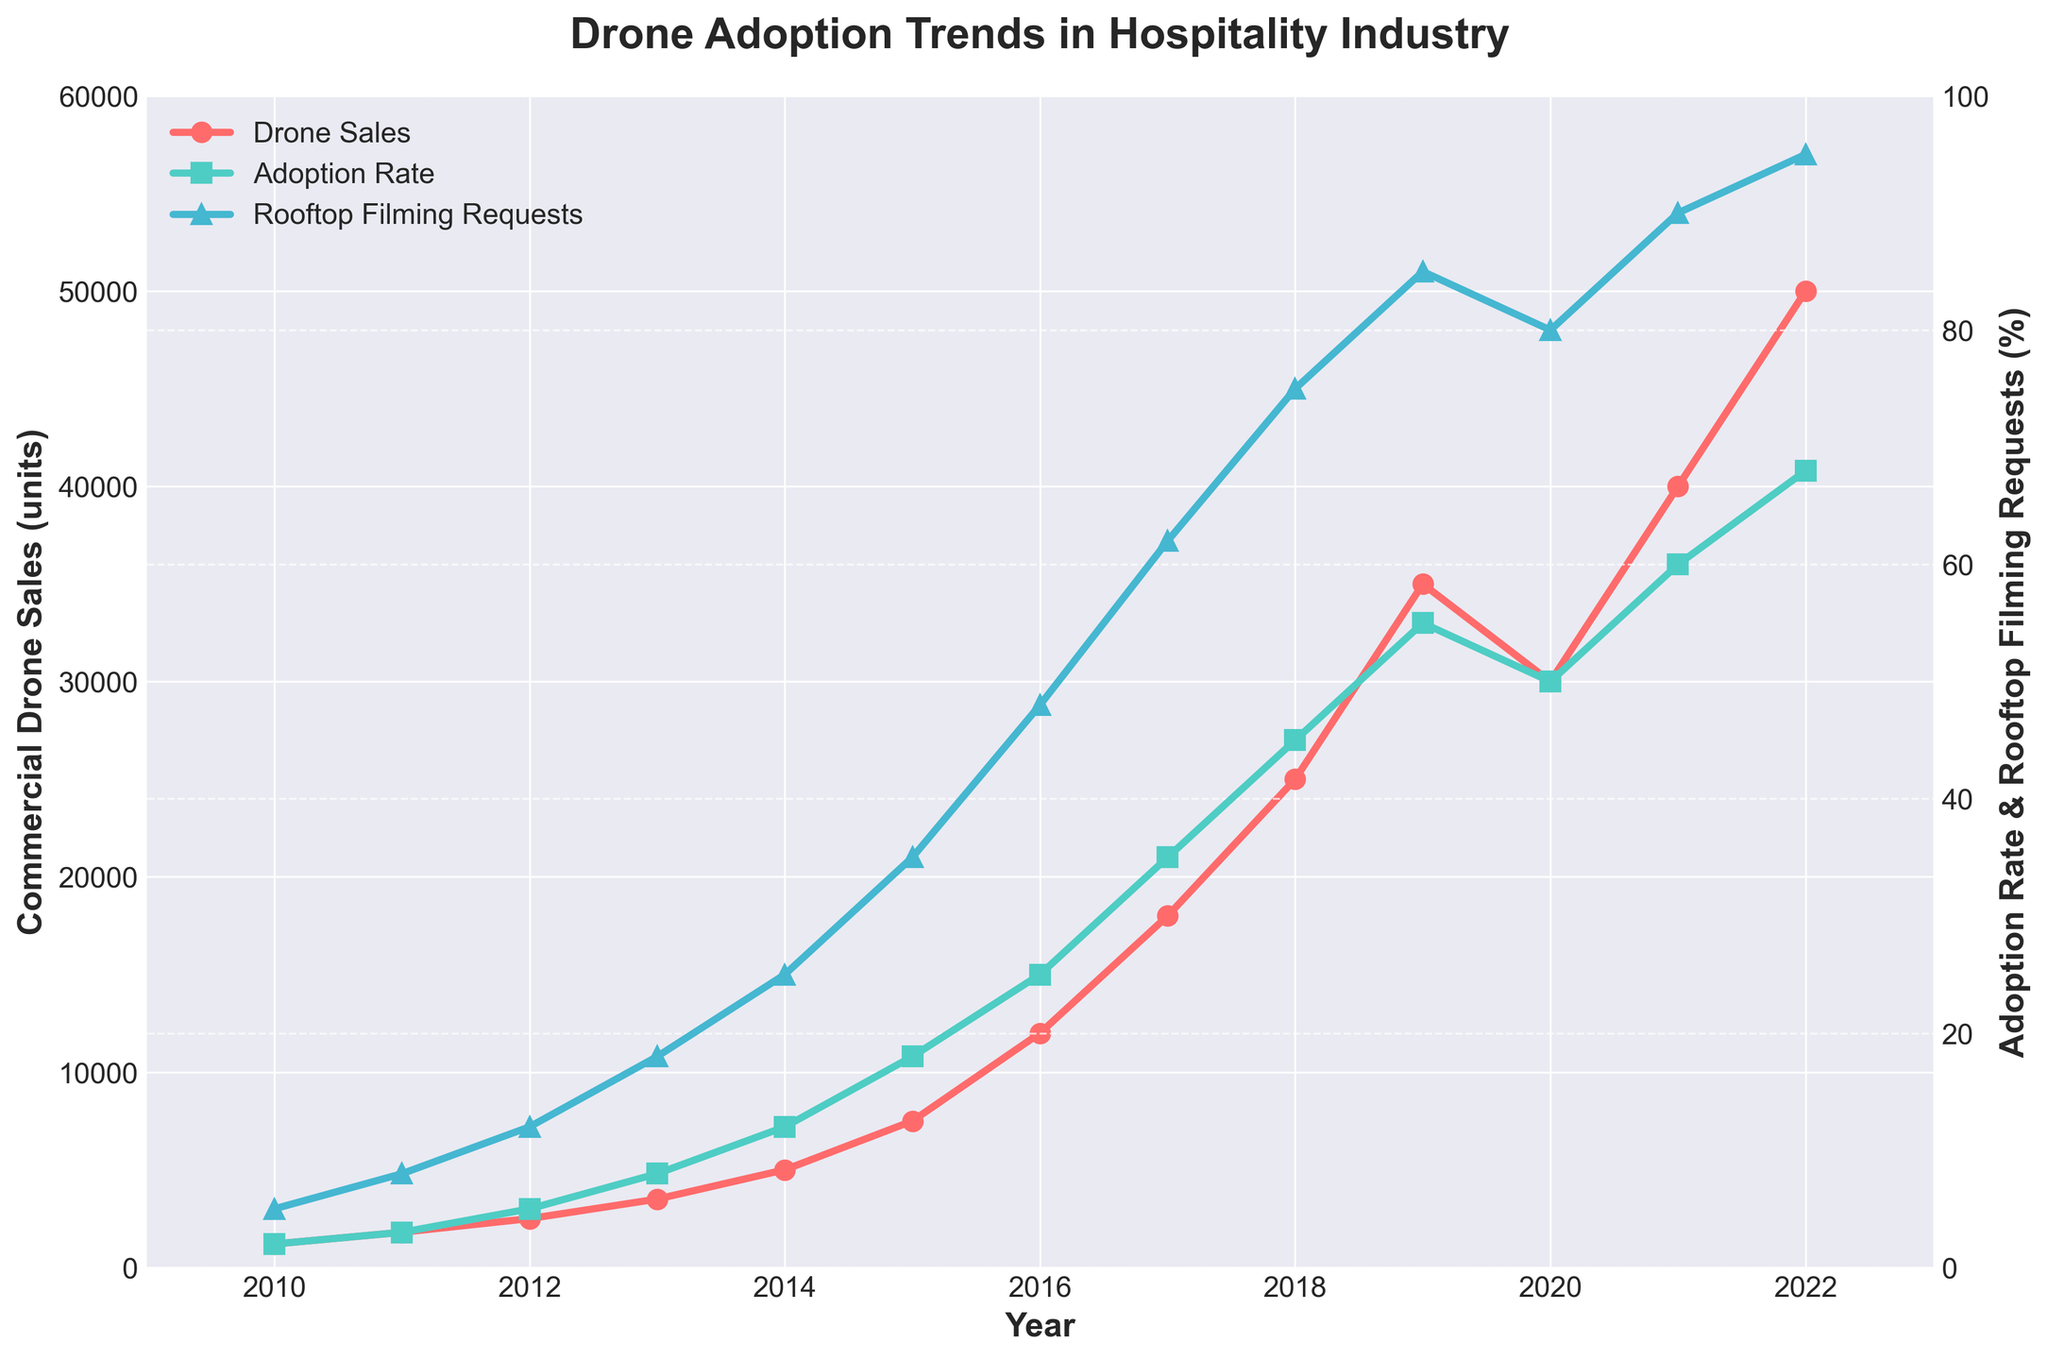what's the trend in commercial drone sales between 2010 and 2022? The data plot shows a steady upward trend in commercial drone sales, increasing from 1200 units in 2010 to 50000 units in 2022. This indicates growing adoption and market expansion over the period.
Answer: Increasing steadily what year shows the highest adoption rate in the hospitality industry? By observing the line for the hospitality industry adoption rate, the year 2022 demonstrates the highest adoption rate at 68%.
Answer: 2022 How does the adoption rate in the hospitality industry and the number of rooftop filming requests compare in 2016? The adoption rate for the hospitality industry in 2016 is around 25%, while the number of rooftop filming requests is around 48%. Thus, the rooftop filming requests are higher.
Answer: Rooftop filming requests are higher What is the average drone price trend from 2010 to 2022? The plot shows that the average drone price is decreasing over time, from $3500 in 2010 to $950 in 2022. This indicates that drones have become more affordable over the years.
Answer: Decreasing Did the DJI market share increase or decrease from 2010 to 2022? The plot shows that DJI market share increased from 45% in 2010 to 82% in 2022, highlighting DJI's growing dominance in the market.
Answer: Increased In which year did the rooftop filming requests reach 62%? By observing the line for rooftop filming requests, it reaches 62% in the year 2017.
Answer: 2017 Which metric had a more rapid growth rate between 2014 and 2019, drone sales or rooftop filming requests? From 2014 to 2019, drone sales increased from 5000 units to 35000 units, whereas rooftop filming requests increased from 25% to 85%. Based on the slopes of the lines, drone sales show a steeper increase.
Answer: Drone sales What was the difference in the adoption rate in the hospitality industry between 2013 and 2021? The adoption rate in the hospitality industry in 2013 was 8%, and in 2021 it was 60%. The difference is 60% - 8% = 52%.
Answer: 52% How did the number of commercial drone sales in 2020 compare to that in 2018? The number of commercial drone sales in 2018 was 25000 units, while in 2020 it was 30000 units. Thus, the sales in 2020 were higher than in 2018.
Answer: Higher in 2020 Which year saw a dramatic increase in rooftop filming requests compared to the previous year? The dramatic increase in rooftop filming requests can be observed between 2016 and 2017, where the percentage jumped from 48% to 62%.
Answer: 2016 to 2017 